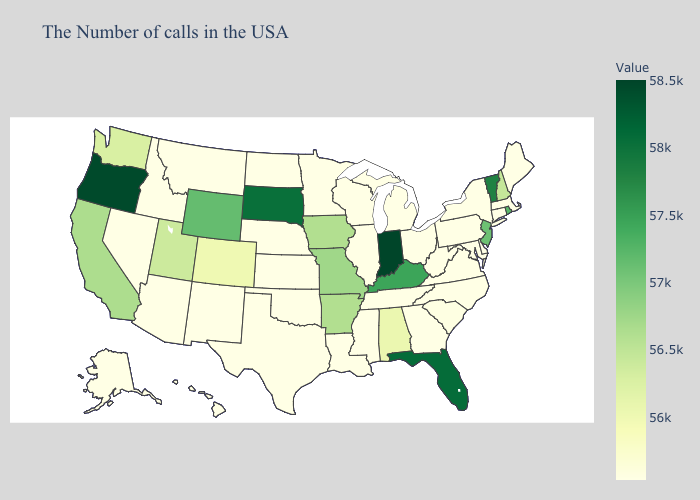Does Wyoming have the lowest value in the USA?
Concise answer only. No. Does Iowa have the lowest value in the MidWest?
Concise answer only. No. Which states hav the highest value in the MidWest?
Write a very short answer. Indiana. Which states have the lowest value in the MidWest?
Answer briefly. Ohio, Michigan, Wisconsin, Illinois, Minnesota, Kansas, Nebraska, North Dakota. Among the states that border Oklahoma , which have the highest value?
Answer briefly. Missouri. 